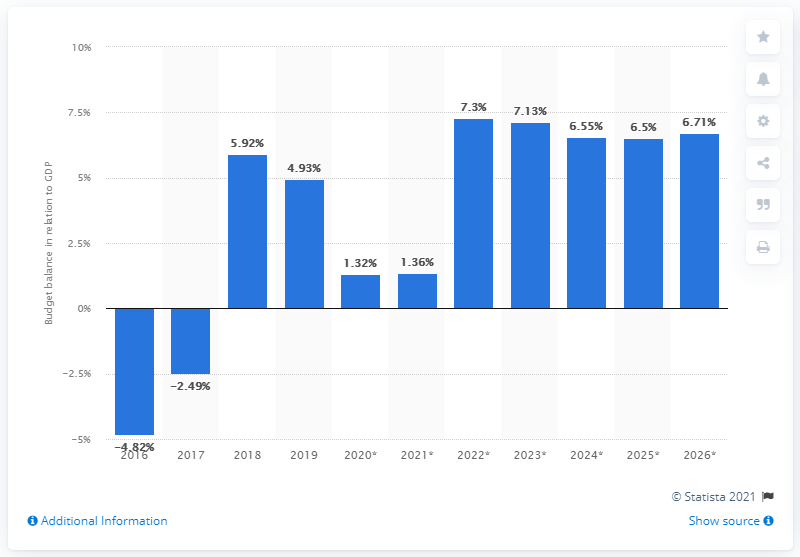Outline some significant characteristics in this image. In 2019, Qatar's budget surplus accounted for 4.93% of its GDP. 